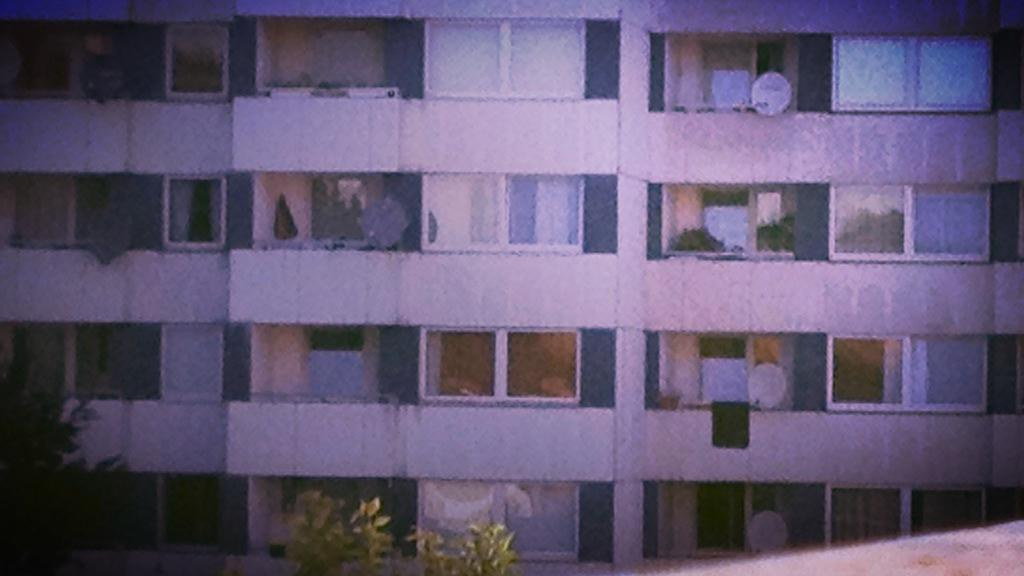What type of structure is visible in the image? There is a building in the image. What features can be seen on the building? The building has doors and windows. What else is present in the image besides the building? There are other objects in the image. What type of vegetation is at the bottom of the image? There are trees at the bottom of the image. Can you tell me how many buns are on the roof of the building in the image? There are no buns present on the roof of the building in the image. What type of insect can be seen flying near the trees at the bottom of the image? There is no insect visible near the trees at the bottom of the image. 